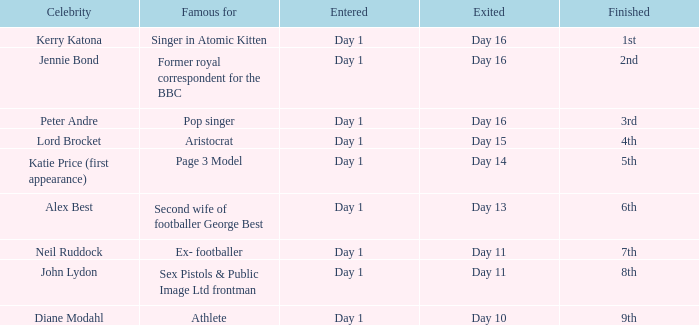Name the entered for famous for page 3 model Day 1. 